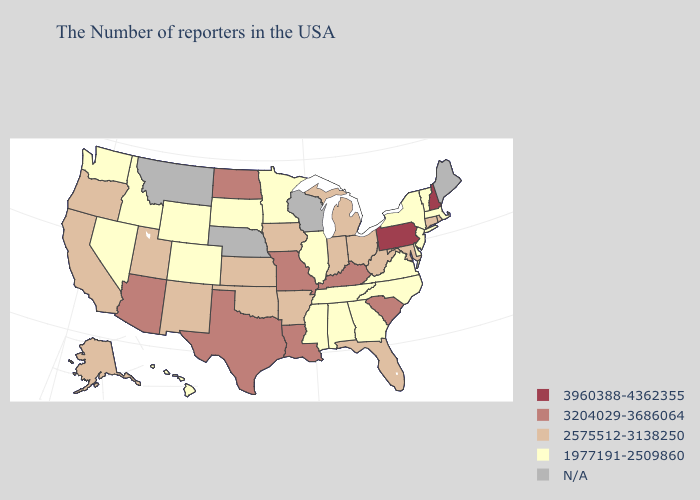Among the states that border Virginia , does Tennessee have the lowest value?
Quick response, please. Yes. Does West Virginia have the highest value in the USA?
Answer briefly. No. What is the lowest value in states that border New York?
Quick response, please. 1977191-2509860. Name the states that have a value in the range 3204029-3686064?
Be succinct. South Carolina, Kentucky, Louisiana, Missouri, Texas, North Dakota, Arizona. Name the states that have a value in the range N/A?
Quick response, please. Maine, Wisconsin, Nebraska, Montana. Does the first symbol in the legend represent the smallest category?
Be succinct. No. How many symbols are there in the legend?
Write a very short answer. 5. Does Tennessee have the highest value in the South?
Give a very brief answer. No. Name the states that have a value in the range 3204029-3686064?
Give a very brief answer. South Carolina, Kentucky, Louisiana, Missouri, Texas, North Dakota, Arizona. Does New Hampshire have the lowest value in the Northeast?
Concise answer only. No. How many symbols are there in the legend?
Quick response, please. 5. Among the states that border New Mexico , does Texas have the highest value?
Concise answer only. Yes. What is the highest value in the South ?
Give a very brief answer. 3204029-3686064. What is the lowest value in the USA?
Answer briefly. 1977191-2509860. Name the states that have a value in the range 3960388-4362355?
Give a very brief answer. New Hampshire, Pennsylvania. 